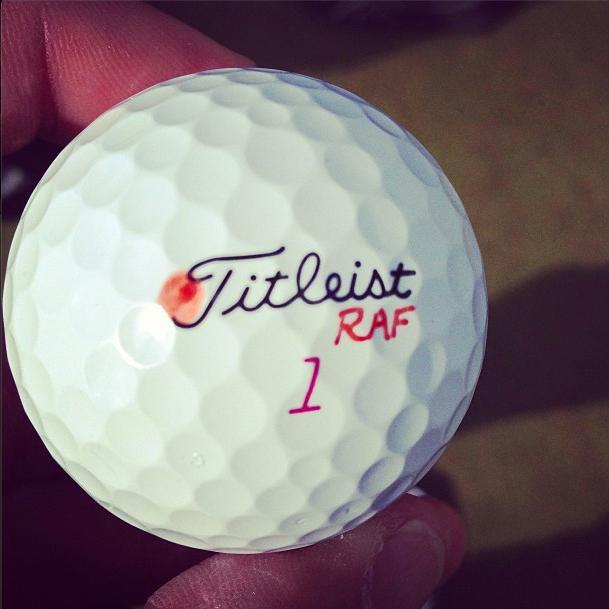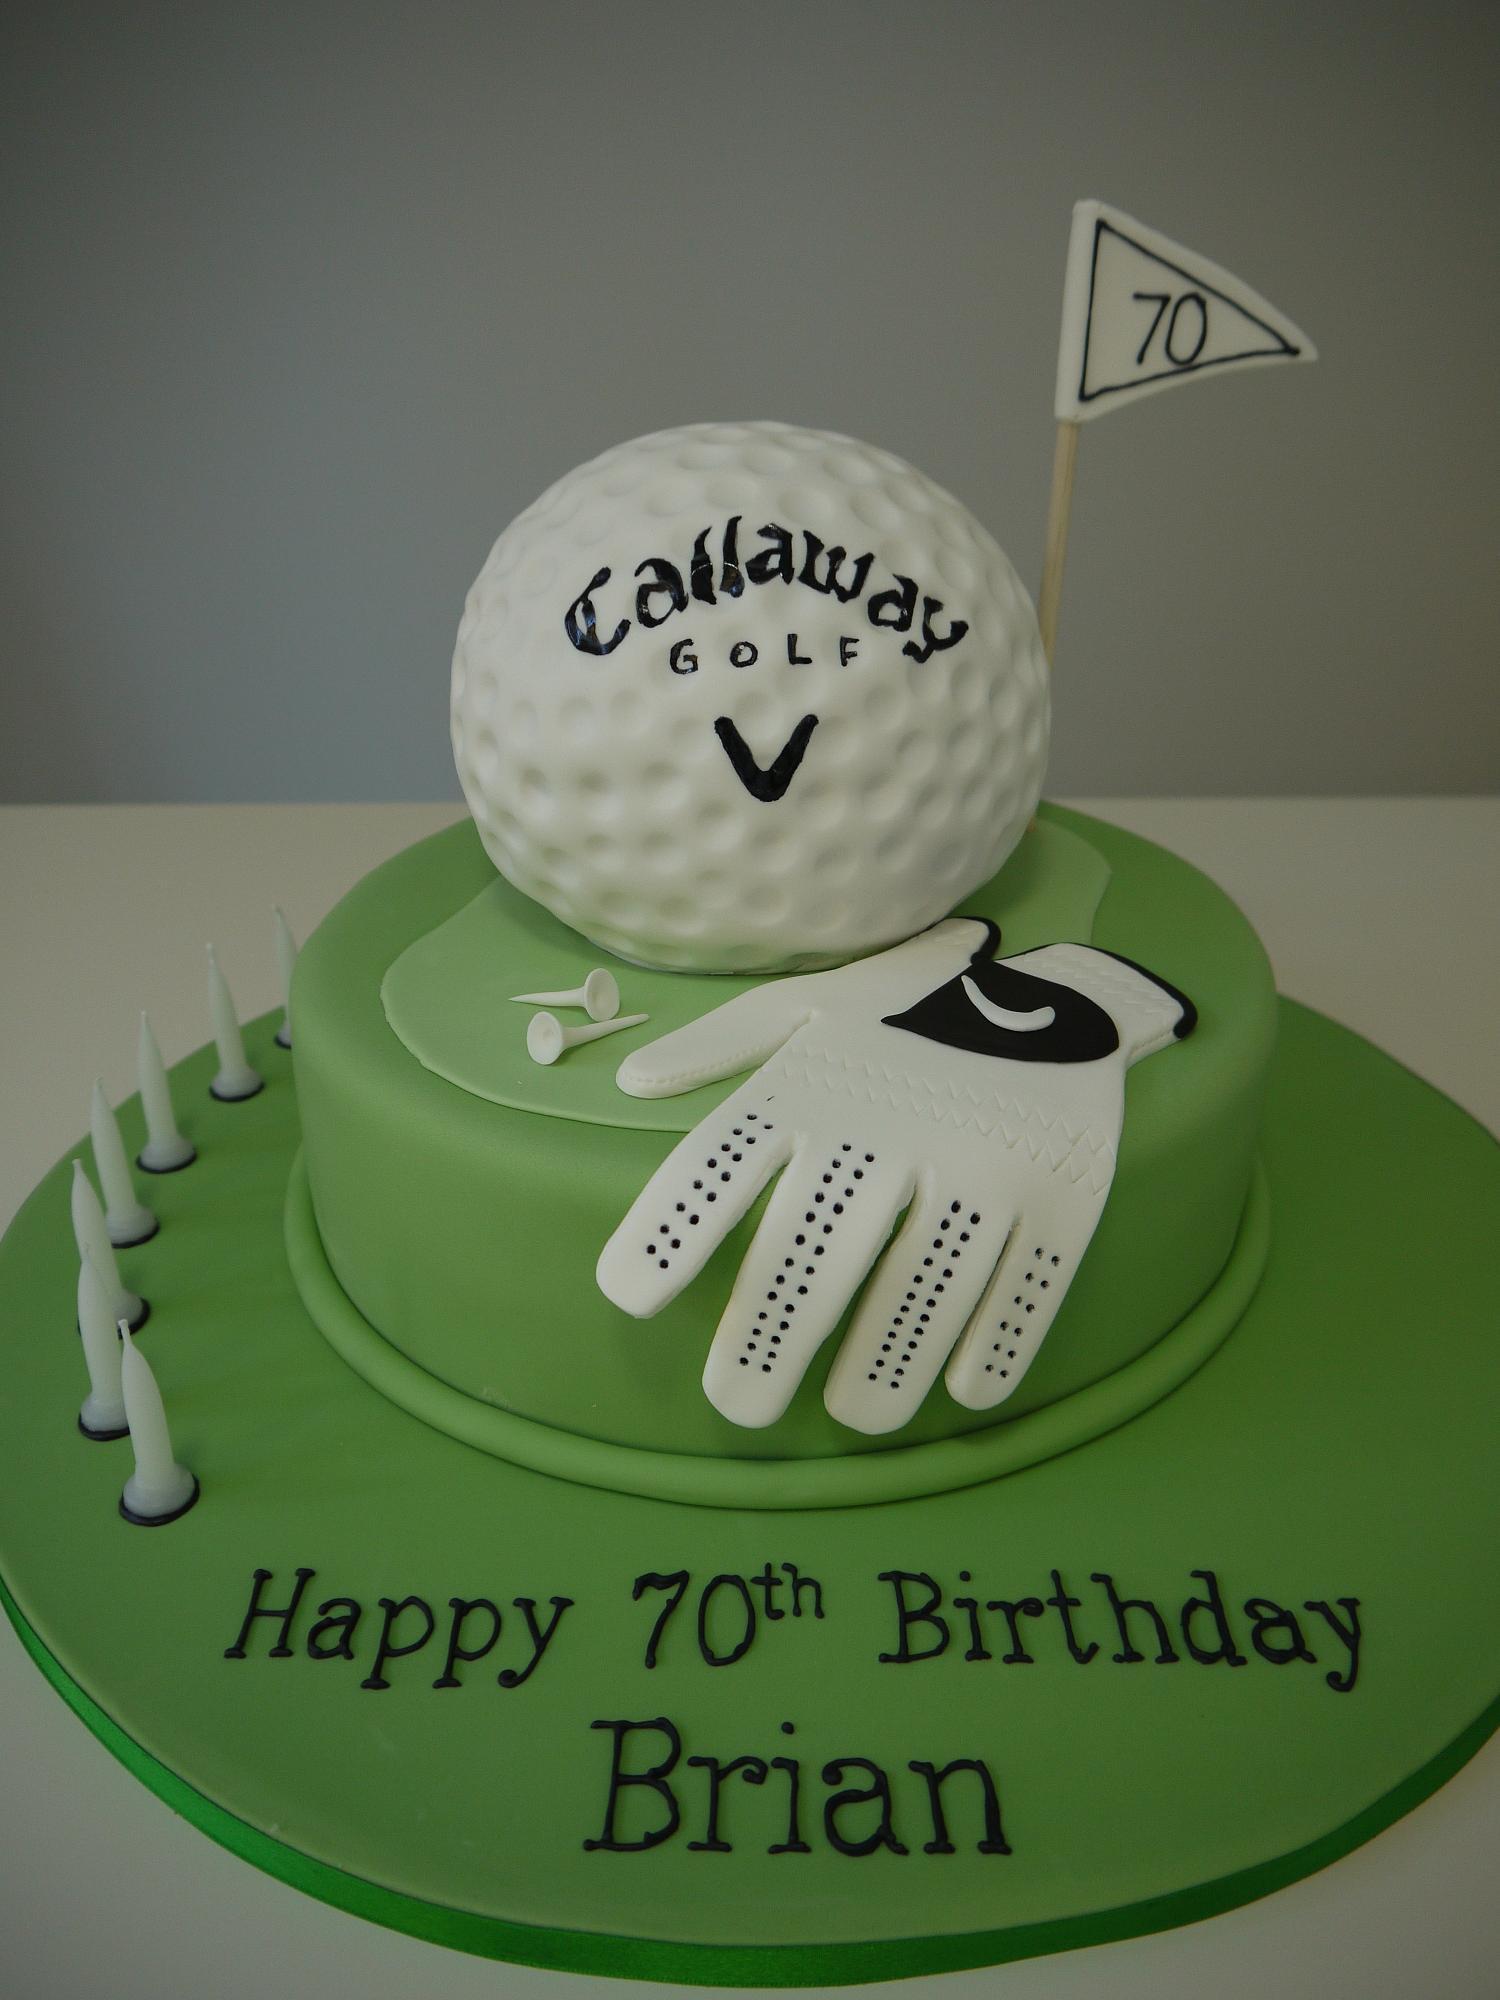The first image is the image on the left, the second image is the image on the right. Analyze the images presented: Is the assertion "The left image is a golf ball with a flower on it." valid? Answer yes or no. No. The first image is the image on the left, the second image is the image on the right. Evaluate the accuracy of this statement regarding the images: "The left and right image contains the same number of playable golf clubs.". Is it true? Answer yes or no. No. 